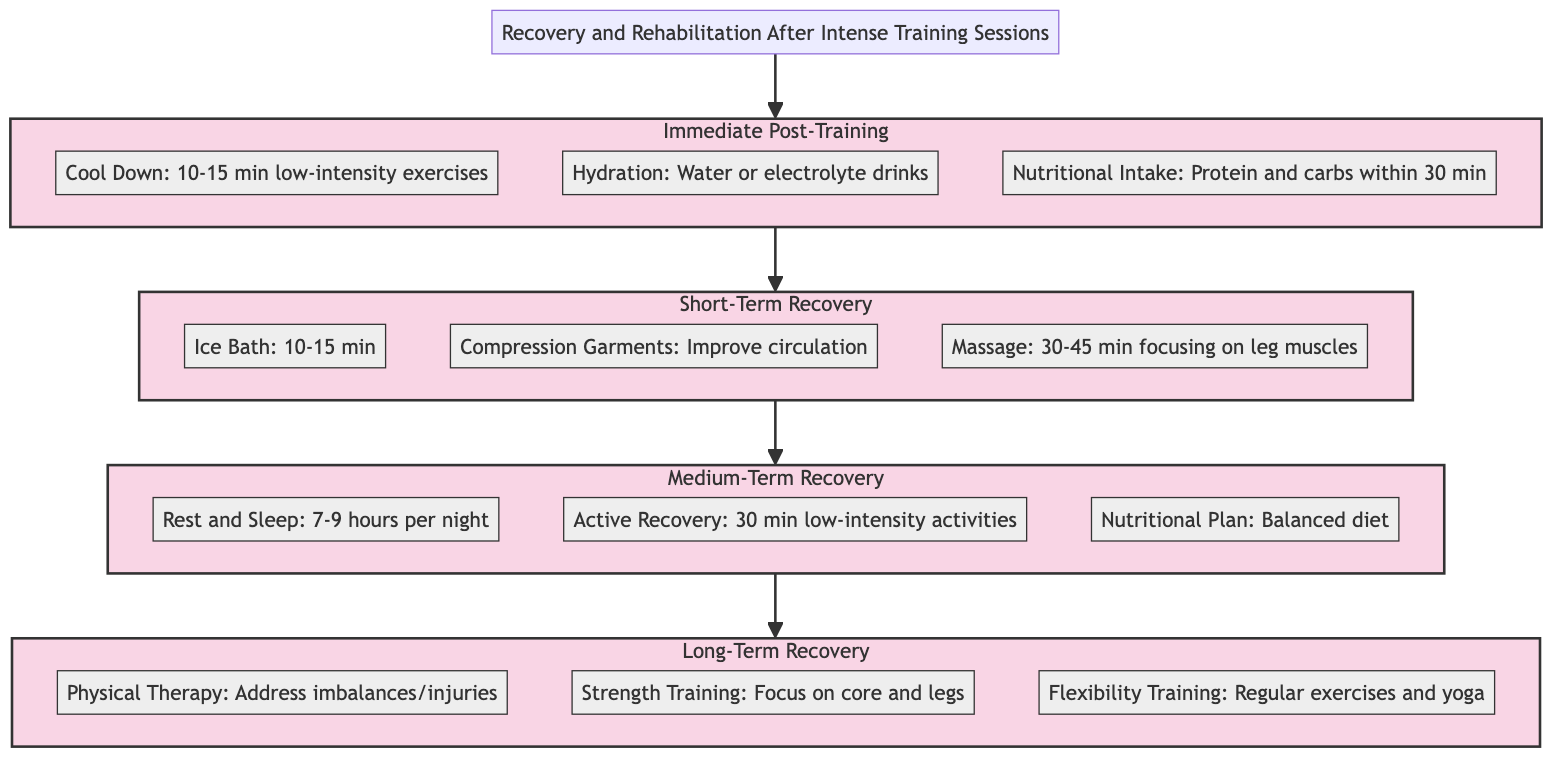What is the first stage listed in the diagram? The diagram lists "Immediate Post-Training" as the first stage immediately following the title.
Answer: Immediate Post-Training How many steps are included in the "Short-Term Recovery" stage? The "Short-Term Recovery" stage includes three specific steps, which can be counted directly from the diagram.
Answer: 3 What step follows "Hydration" in the "Immediate Post-Training" stage? Following "Hydration," the next step is "Nutritional Intake," as the flow indicates the order of steps within the stage.
Answer: Nutritional Intake What is the total number of stages in this clinical pathway? The diagram shows four distinct stages, which can be counted sequentially.
Answer: 4 Which step focuses on muscle tightness alleviation in the "Short-Term Recovery" stage? In the "Short-Term Recovery" stage, the step that focuses on alleviating muscle tightness is "Massage." This is identified from the list of steps in that stage.
Answer: Massage What type of activity is recommended in the "Medium-Term Recovery" stage? In the "Medium-Term Recovery" stage, "Active Recovery," which involves low-intensity activities, is recommended to maintain blood flow.
Answer: Active Recovery What element in the "Long-Term Recovery" stage addresses injuries? The element that specifically addresses injuries in the "Long-Term Recovery" stage is "Physical Therapy." It can be found as part of the insights in that stage.
Answer: Physical Therapy Which step includes nutritional advice in the "Immediate Post-Training" stage? The step that includes nutritional advice is "Nutritional Intake," specifically mentioning the importance of eating within 30 minutes post-training.
Answer: Nutritional Intake What is the purpose of "Compression Garments" in the "Short-Term Recovery" stage? The purpose is to improve blood circulation and reduce swelling, as stated in the description provided for that step.
Answer: Improve circulation 